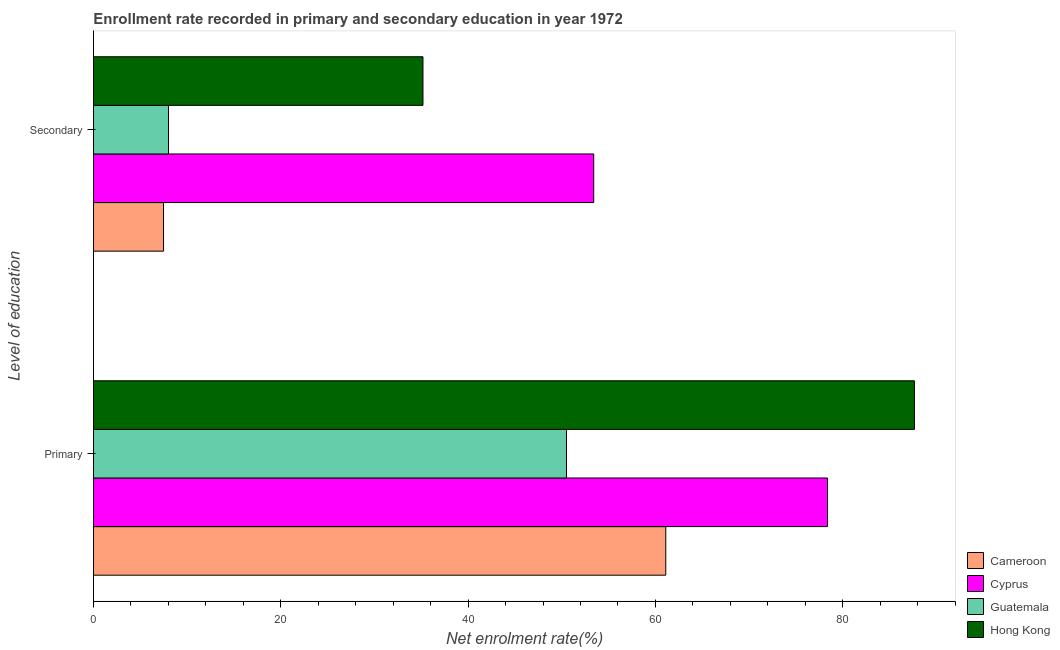How many bars are there on the 1st tick from the bottom?
Make the answer very short. 4. What is the label of the 1st group of bars from the top?
Keep it short and to the point. Secondary. What is the enrollment rate in primary education in Hong Kong?
Give a very brief answer. 87.66. Across all countries, what is the maximum enrollment rate in primary education?
Your answer should be compact. 87.66. Across all countries, what is the minimum enrollment rate in primary education?
Your response must be concise. 50.51. In which country was the enrollment rate in primary education maximum?
Your answer should be compact. Hong Kong. In which country was the enrollment rate in primary education minimum?
Offer a terse response. Guatemala. What is the total enrollment rate in primary education in the graph?
Your response must be concise. 277.66. What is the difference between the enrollment rate in secondary education in Hong Kong and that in Guatemala?
Provide a short and direct response. 27.17. What is the difference between the enrollment rate in primary education in Guatemala and the enrollment rate in secondary education in Cyprus?
Give a very brief answer. -2.91. What is the average enrollment rate in primary education per country?
Ensure brevity in your answer.  69.41. What is the difference between the enrollment rate in secondary education and enrollment rate in primary education in Cameroon?
Offer a terse response. -53.63. In how many countries, is the enrollment rate in primary education greater than 12 %?
Your answer should be compact. 4. What is the ratio of the enrollment rate in secondary education in Cyprus to that in Guatemala?
Your answer should be very brief. 6.67. Is the enrollment rate in secondary education in Cyprus less than that in Guatemala?
Offer a very short reply. No. In how many countries, is the enrollment rate in secondary education greater than the average enrollment rate in secondary education taken over all countries?
Your answer should be compact. 2. What does the 4th bar from the top in Secondary represents?
Ensure brevity in your answer.  Cameroon. What does the 2nd bar from the bottom in Secondary represents?
Offer a very short reply. Cyprus. How many bars are there?
Give a very brief answer. 8. How many countries are there in the graph?
Make the answer very short. 4. Does the graph contain any zero values?
Provide a short and direct response. No. What is the title of the graph?
Ensure brevity in your answer.  Enrollment rate recorded in primary and secondary education in year 1972. What is the label or title of the X-axis?
Your response must be concise. Net enrolment rate(%). What is the label or title of the Y-axis?
Keep it short and to the point. Level of education. What is the Net enrolment rate(%) in Cameroon in Primary?
Make the answer very short. 61.11. What is the Net enrolment rate(%) in Cyprus in Primary?
Provide a succinct answer. 78.38. What is the Net enrolment rate(%) of Guatemala in Primary?
Offer a terse response. 50.51. What is the Net enrolment rate(%) in Hong Kong in Primary?
Offer a very short reply. 87.66. What is the Net enrolment rate(%) of Cameroon in Secondary?
Provide a succinct answer. 7.48. What is the Net enrolment rate(%) in Cyprus in Secondary?
Ensure brevity in your answer.  53.42. What is the Net enrolment rate(%) of Guatemala in Secondary?
Give a very brief answer. 8.01. What is the Net enrolment rate(%) of Hong Kong in Secondary?
Offer a very short reply. 35.18. Across all Level of education, what is the maximum Net enrolment rate(%) in Cameroon?
Your response must be concise. 61.11. Across all Level of education, what is the maximum Net enrolment rate(%) of Cyprus?
Your response must be concise. 78.38. Across all Level of education, what is the maximum Net enrolment rate(%) of Guatemala?
Your response must be concise. 50.51. Across all Level of education, what is the maximum Net enrolment rate(%) in Hong Kong?
Make the answer very short. 87.66. Across all Level of education, what is the minimum Net enrolment rate(%) of Cameroon?
Your response must be concise. 7.48. Across all Level of education, what is the minimum Net enrolment rate(%) in Cyprus?
Provide a succinct answer. 53.42. Across all Level of education, what is the minimum Net enrolment rate(%) of Guatemala?
Your answer should be very brief. 8.01. Across all Level of education, what is the minimum Net enrolment rate(%) of Hong Kong?
Your response must be concise. 35.18. What is the total Net enrolment rate(%) in Cameroon in the graph?
Your answer should be very brief. 68.59. What is the total Net enrolment rate(%) of Cyprus in the graph?
Provide a short and direct response. 131.8. What is the total Net enrolment rate(%) of Guatemala in the graph?
Your answer should be compact. 58.52. What is the total Net enrolment rate(%) in Hong Kong in the graph?
Keep it short and to the point. 122.84. What is the difference between the Net enrolment rate(%) of Cameroon in Primary and that in Secondary?
Provide a short and direct response. 53.63. What is the difference between the Net enrolment rate(%) of Cyprus in Primary and that in Secondary?
Your answer should be compact. 24.96. What is the difference between the Net enrolment rate(%) of Guatemala in Primary and that in Secondary?
Ensure brevity in your answer.  42.5. What is the difference between the Net enrolment rate(%) of Hong Kong in Primary and that in Secondary?
Provide a short and direct response. 52.48. What is the difference between the Net enrolment rate(%) of Cameroon in Primary and the Net enrolment rate(%) of Cyprus in Secondary?
Ensure brevity in your answer.  7.69. What is the difference between the Net enrolment rate(%) of Cameroon in Primary and the Net enrolment rate(%) of Guatemala in Secondary?
Keep it short and to the point. 53.1. What is the difference between the Net enrolment rate(%) in Cameroon in Primary and the Net enrolment rate(%) in Hong Kong in Secondary?
Make the answer very short. 25.93. What is the difference between the Net enrolment rate(%) of Cyprus in Primary and the Net enrolment rate(%) of Guatemala in Secondary?
Keep it short and to the point. 70.37. What is the difference between the Net enrolment rate(%) of Cyprus in Primary and the Net enrolment rate(%) of Hong Kong in Secondary?
Provide a succinct answer. 43.2. What is the difference between the Net enrolment rate(%) in Guatemala in Primary and the Net enrolment rate(%) in Hong Kong in Secondary?
Your response must be concise. 15.33. What is the average Net enrolment rate(%) in Cameroon per Level of education?
Your answer should be compact. 34.3. What is the average Net enrolment rate(%) in Cyprus per Level of education?
Keep it short and to the point. 65.9. What is the average Net enrolment rate(%) of Guatemala per Level of education?
Your answer should be compact. 29.26. What is the average Net enrolment rate(%) in Hong Kong per Level of education?
Provide a succinct answer. 61.42. What is the difference between the Net enrolment rate(%) of Cameroon and Net enrolment rate(%) of Cyprus in Primary?
Your answer should be very brief. -17.27. What is the difference between the Net enrolment rate(%) of Cameroon and Net enrolment rate(%) of Guatemala in Primary?
Offer a very short reply. 10.6. What is the difference between the Net enrolment rate(%) in Cameroon and Net enrolment rate(%) in Hong Kong in Primary?
Offer a very short reply. -26.55. What is the difference between the Net enrolment rate(%) in Cyprus and Net enrolment rate(%) in Guatemala in Primary?
Make the answer very short. 27.87. What is the difference between the Net enrolment rate(%) in Cyprus and Net enrolment rate(%) in Hong Kong in Primary?
Offer a very short reply. -9.28. What is the difference between the Net enrolment rate(%) in Guatemala and Net enrolment rate(%) in Hong Kong in Primary?
Your answer should be very brief. -37.15. What is the difference between the Net enrolment rate(%) in Cameroon and Net enrolment rate(%) in Cyprus in Secondary?
Offer a very short reply. -45.93. What is the difference between the Net enrolment rate(%) of Cameroon and Net enrolment rate(%) of Guatemala in Secondary?
Your response must be concise. -0.53. What is the difference between the Net enrolment rate(%) of Cameroon and Net enrolment rate(%) of Hong Kong in Secondary?
Provide a succinct answer. -27.7. What is the difference between the Net enrolment rate(%) in Cyprus and Net enrolment rate(%) in Guatemala in Secondary?
Keep it short and to the point. 45.4. What is the difference between the Net enrolment rate(%) in Cyprus and Net enrolment rate(%) in Hong Kong in Secondary?
Provide a short and direct response. 18.23. What is the difference between the Net enrolment rate(%) in Guatemala and Net enrolment rate(%) in Hong Kong in Secondary?
Ensure brevity in your answer.  -27.17. What is the ratio of the Net enrolment rate(%) of Cameroon in Primary to that in Secondary?
Offer a very short reply. 8.17. What is the ratio of the Net enrolment rate(%) of Cyprus in Primary to that in Secondary?
Provide a succinct answer. 1.47. What is the ratio of the Net enrolment rate(%) of Guatemala in Primary to that in Secondary?
Your response must be concise. 6.3. What is the ratio of the Net enrolment rate(%) of Hong Kong in Primary to that in Secondary?
Give a very brief answer. 2.49. What is the difference between the highest and the second highest Net enrolment rate(%) of Cameroon?
Ensure brevity in your answer.  53.63. What is the difference between the highest and the second highest Net enrolment rate(%) in Cyprus?
Provide a short and direct response. 24.96. What is the difference between the highest and the second highest Net enrolment rate(%) in Guatemala?
Ensure brevity in your answer.  42.5. What is the difference between the highest and the second highest Net enrolment rate(%) of Hong Kong?
Your answer should be compact. 52.48. What is the difference between the highest and the lowest Net enrolment rate(%) in Cameroon?
Give a very brief answer. 53.63. What is the difference between the highest and the lowest Net enrolment rate(%) in Cyprus?
Ensure brevity in your answer.  24.96. What is the difference between the highest and the lowest Net enrolment rate(%) of Guatemala?
Your answer should be compact. 42.5. What is the difference between the highest and the lowest Net enrolment rate(%) in Hong Kong?
Keep it short and to the point. 52.48. 